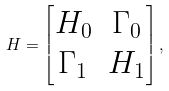<formula> <loc_0><loc_0><loc_500><loc_500>H = \begin{bmatrix} H _ { 0 } & \Gamma _ { 0 } \\ \Gamma _ { 1 } & H _ { 1 } \\ \end{bmatrix} ,</formula> 